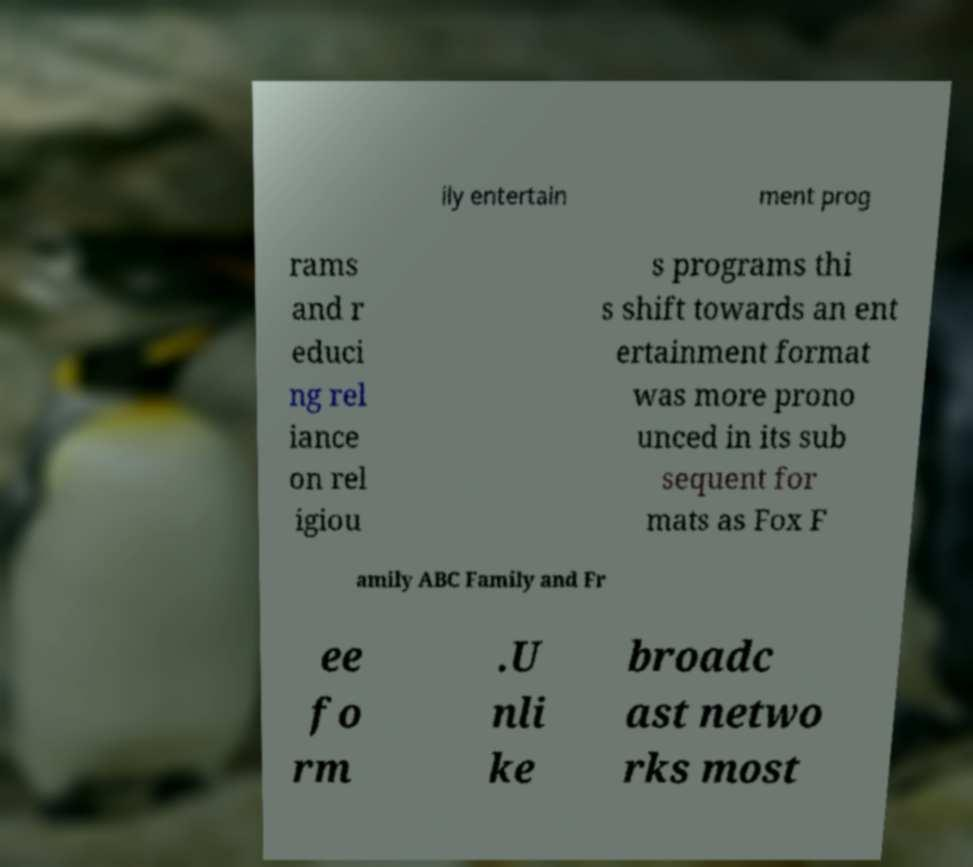What messages or text are displayed in this image? I need them in a readable, typed format. ily entertain ment prog rams and r educi ng rel iance on rel igiou s programs thi s shift towards an ent ertainment format was more prono unced in its sub sequent for mats as Fox F amily ABC Family and Fr ee fo rm .U nli ke broadc ast netwo rks most 